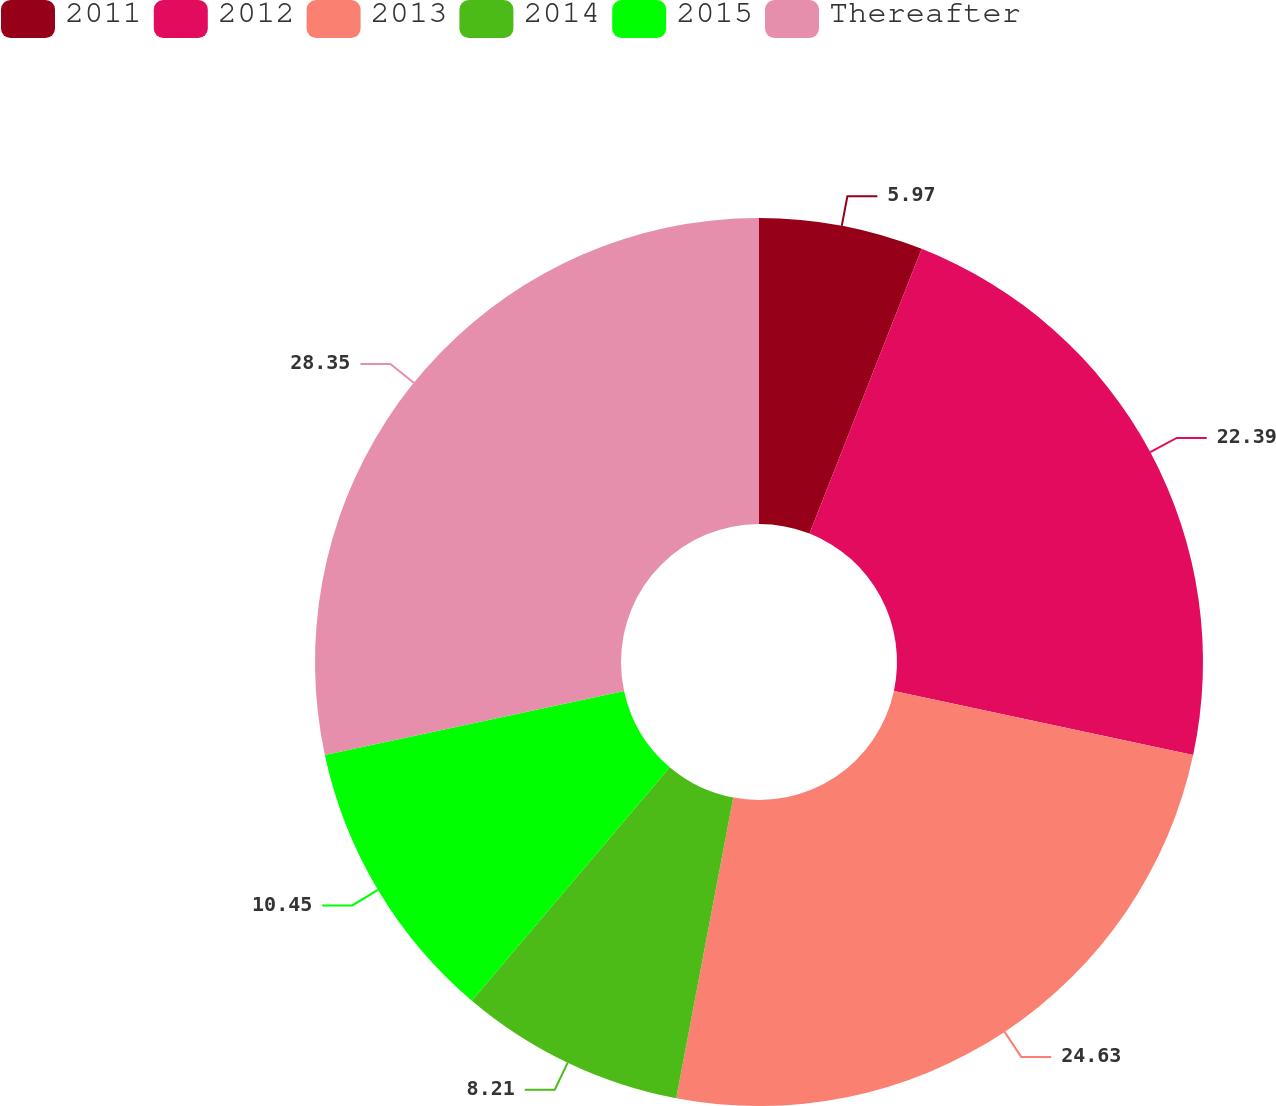<chart> <loc_0><loc_0><loc_500><loc_500><pie_chart><fcel>2011<fcel>2012<fcel>2013<fcel>2014<fcel>2015<fcel>Thereafter<nl><fcel>5.97%<fcel>22.39%<fcel>24.63%<fcel>8.21%<fcel>10.45%<fcel>28.36%<nl></chart> 